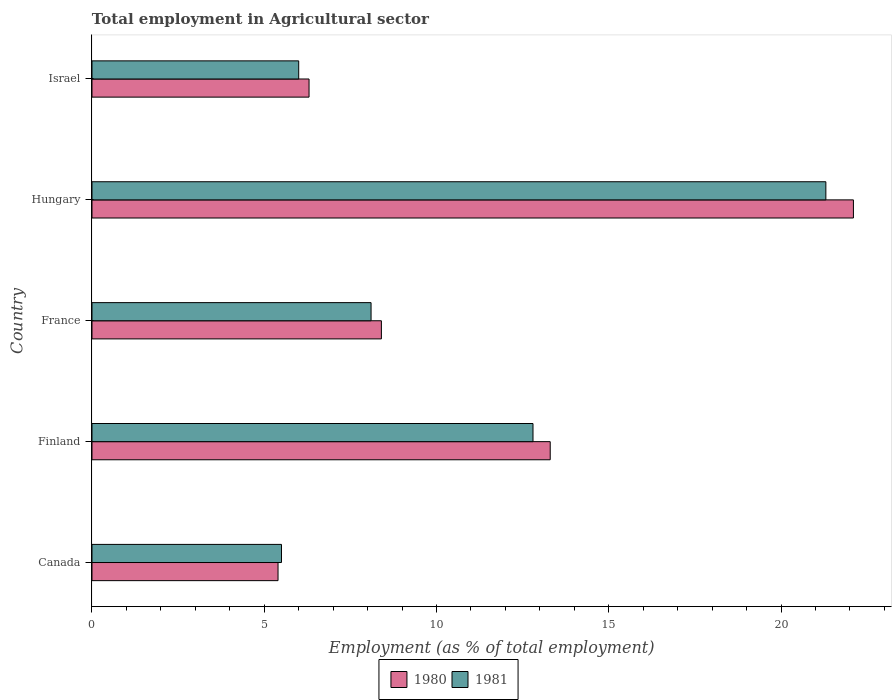How many different coloured bars are there?
Make the answer very short. 2. How many groups of bars are there?
Offer a terse response. 5. Are the number of bars per tick equal to the number of legend labels?
Your answer should be compact. Yes. Are the number of bars on each tick of the Y-axis equal?
Keep it short and to the point. Yes. How many bars are there on the 3rd tick from the top?
Your answer should be compact. 2. How many bars are there on the 2nd tick from the bottom?
Offer a terse response. 2. What is the label of the 3rd group of bars from the top?
Provide a short and direct response. France. In how many cases, is the number of bars for a given country not equal to the number of legend labels?
Your answer should be very brief. 0. What is the employment in agricultural sector in 1980 in Canada?
Ensure brevity in your answer.  5.4. Across all countries, what is the maximum employment in agricultural sector in 1980?
Your response must be concise. 22.1. Across all countries, what is the minimum employment in agricultural sector in 1981?
Your answer should be very brief. 5.5. In which country was the employment in agricultural sector in 1981 maximum?
Offer a very short reply. Hungary. In which country was the employment in agricultural sector in 1980 minimum?
Your answer should be compact. Canada. What is the total employment in agricultural sector in 1981 in the graph?
Your answer should be very brief. 53.7. What is the difference between the employment in agricultural sector in 1981 in Canada and that in Hungary?
Provide a succinct answer. -15.8. What is the difference between the employment in agricultural sector in 1981 in Israel and the employment in agricultural sector in 1980 in Canada?
Give a very brief answer. 0.6. What is the average employment in agricultural sector in 1981 per country?
Provide a short and direct response. 10.74. In how many countries, is the employment in agricultural sector in 1981 greater than 19 %?
Provide a succinct answer. 1. What is the ratio of the employment in agricultural sector in 1981 in Finland to that in France?
Ensure brevity in your answer.  1.58. Is the employment in agricultural sector in 1981 in Finland less than that in Hungary?
Give a very brief answer. Yes. Is the difference between the employment in agricultural sector in 1981 in France and Israel greater than the difference between the employment in agricultural sector in 1980 in France and Israel?
Make the answer very short. Yes. What is the difference between the highest and the second highest employment in agricultural sector in 1980?
Ensure brevity in your answer.  8.8. What is the difference between the highest and the lowest employment in agricultural sector in 1980?
Your response must be concise. 16.7. What does the 1st bar from the bottom in Canada represents?
Provide a succinct answer. 1980. How many bars are there?
Provide a succinct answer. 10. Are the values on the major ticks of X-axis written in scientific E-notation?
Keep it short and to the point. No. Where does the legend appear in the graph?
Your answer should be compact. Bottom center. What is the title of the graph?
Make the answer very short. Total employment in Agricultural sector. What is the label or title of the X-axis?
Offer a very short reply. Employment (as % of total employment). What is the label or title of the Y-axis?
Offer a terse response. Country. What is the Employment (as % of total employment) in 1980 in Canada?
Your answer should be compact. 5.4. What is the Employment (as % of total employment) in 1981 in Canada?
Make the answer very short. 5.5. What is the Employment (as % of total employment) in 1980 in Finland?
Your answer should be very brief. 13.3. What is the Employment (as % of total employment) in 1981 in Finland?
Make the answer very short. 12.8. What is the Employment (as % of total employment) in 1980 in France?
Provide a succinct answer. 8.4. What is the Employment (as % of total employment) in 1981 in France?
Your answer should be compact. 8.1. What is the Employment (as % of total employment) in 1980 in Hungary?
Your answer should be compact. 22.1. What is the Employment (as % of total employment) of 1981 in Hungary?
Provide a succinct answer. 21.3. What is the Employment (as % of total employment) of 1980 in Israel?
Provide a succinct answer. 6.3. Across all countries, what is the maximum Employment (as % of total employment) of 1980?
Ensure brevity in your answer.  22.1. Across all countries, what is the maximum Employment (as % of total employment) of 1981?
Make the answer very short. 21.3. Across all countries, what is the minimum Employment (as % of total employment) in 1980?
Offer a terse response. 5.4. Across all countries, what is the minimum Employment (as % of total employment) in 1981?
Your answer should be compact. 5.5. What is the total Employment (as % of total employment) in 1980 in the graph?
Your answer should be very brief. 55.5. What is the total Employment (as % of total employment) of 1981 in the graph?
Make the answer very short. 53.7. What is the difference between the Employment (as % of total employment) in 1981 in Canada and that in France?
Your answer should be compact. -2.6. What is the difference between the Employment (as % of total employment) in 1980 in Canada and that in Hungary?
Your answer should be very brief. -16.7. What is the difference between the Employment (as % of total employment) of 1981 in Canada and that in Hungary?
Make the answer very short. -15.8. What is the difference between the Employment (as % of total employment) in 1980 in Canada and that in Israel?
Keep it short and to the point. -0.9. What is the difference between the Employment (as % of total employment) in 1981 in Canada and that in Israel?
Make the answer very short. -0.5. What is the difference between the Employment (as % of total employment) in 1981 in Finland and that in France?
Provide a succinct answer. 4.7. What is the difference between the Employment (as % of total employment) of 1980 in Finland and that in Hungary?
Your answer should be very brief. -8.8. What is the difference between the Employment (as % of total employment) of 1980 in Finland and that in Israel?
Offer a terse response. 7. What is the difference between the Employment (as % of total employment) in 1981 in Finland and that in Israel?
Make the answer very short. 6.8. What is the difference between the Employment (as % of total employment) of 1980 in France and that in Hungary?
Provide a succinct answer. -13.7. What is the difference between the Employment (as % of total employment) in 1980 in France and that in Israel?
Offer a terse response. 2.1. What is the difference between the Employment (as % of total employment) in 1981 in France and that in Israel?
Give a very brief answer. 2.1. What is the difference between the Employment (as % of total employment) in 1980 in Hungary and that in Israel?
Your answer should be very brief. 15.8. What is the difference between the Employment (as % of total employment) in 1980 in Canada and the Employment (as % of total employment) in 1981 in Finland?
Keep it short and to the point. -7.4. What is the difference between the Employment (as % of total employment) of 1980 in Canada and the Employment (as % of total employment) of 1981 in Hungary?
Offer a very short reply. -15.9. What is the difference between the Employment (as % of total employment) of 1980 in Finland and the Employment (as % of total employment) of 1981 in France?
Ensure brevity in your answer.  5.2. What is the difference between the Employment (as % of total employment) of 1980 in Finland and the Employment (as % of total employment) of 1981 in Israel?
Keep it short and to the point. 7.3. What is the difference between the Employment (as % of total employment) in 1980 in France and the Employment (as % of total employment) in 1981 in Hungary?
Give a very brief answer. -12.9. What is the average Employment (as % of total employment) of 1981 per country?
Your response must be concise. 10.74. What is the difference between the Employment (as % of total employment) in 1980 and Employment (as % of total employment) in 1981 in Finland?
Give a very brief answer. 0.5. What is the difference between the Employment (as % of total employment) in 1980 and Employment (as % of total employment) in 1981 in France?
Provide a short and direct response. 0.3. What is the difference between the Employment (as % of total employment) in 1980 and Employment (as % of total employment) in 1981 in Hungary?
Your answer should be compact. 0.8. What is the difference between the Employment (as % of total employment) of 1980 and Employment (as % of total employment) of 1981 in Israel?
Offer a very short reply. 0.3. What is the ratio of the Employment (as % of total employment) in 1980 in Canada to that in Finland?
Keep it short and to the point. 0.41. What is the ratio of the Employment (as % of total employment) of 1981 in Canada to that in Finland?
Give a very brief answer. 0.43. What is the ratio of the Employment (as % of total employment) of 1980 in Canada to that in France?
Keep it short and to the point. 0.64. What is the ratio of the Employment (as % of total employment) of 1981 in Canada to that in France?
Ensure brevity in your answer.  0.68. What is the ratio of the Employment (as % of total employment) in 1980 in Canada to that in Hungary?
Make the answer very short. 0.24. What is the ratio of the Employment (as % of total employment) in 1981 in Canada to that in Hungary?
Your answer should be very brief. 0.26. What is the ratio of the Employment (as % of total employment) of 1980 in Canada to that in Israel?
Give a very brief answer. 0.86. What is the ratio of the Employment (as % of total employment) of 1980 in Finland to that in France?
Your answer should be compact. 1.58. What is the ratio of the Employment (as % of total employment) of 1981 in Finland to that in France?
Keep it short and to the point. 1.58. What is the ratio of the Employment (as % of total employment) of 1980 in Finland to that in Hungary?
Keep it short and to the point. 0.6. What is the ratio of the Employment (as % of total employment) in 1981 in Finland to that in Hungary?
Give a very brief answer. 0.6. What is the ratio of the Employment (as % of total employment) of 1980 in Finland to that in Israel?
Your answer should be very brief. 2.11. What is the ratio of the Employment (as % of total employment) in 1981 in Finland to that in Israel?
Provide a succinct answer. 2.13. What is the ratio of the Employment (as % of total employment) in 1980 in France to that in Hungary?
Make the answer very short. 0.38. What is the ratio of the Employment (as % of total employment) of 1981 in France to that in Hungary?
Make the answer very short. 0.38. What is the ratio of the Employment (as % of total employment) in 1980 in France to that in Israel?
Your response must be concise. 1.33. What is the ratio of the Employment (as % of total employment) in 1981 in France to that in Israel?
Keep it short and to the point. 1.35. What is the ratio of the Employment (as % of total employment) in 1980 in Hungary to that in Israel?
Give a very brief answer. 3.51. What is the ratio of the Employment (as % of total employment) in 1981 in Hungary to that in Israel?
Your response must be concise. 3.55. What is the difference between the highest and the lowest Employment (as % of total employment) of 1980?
Give a very brief answer. 16.7. 